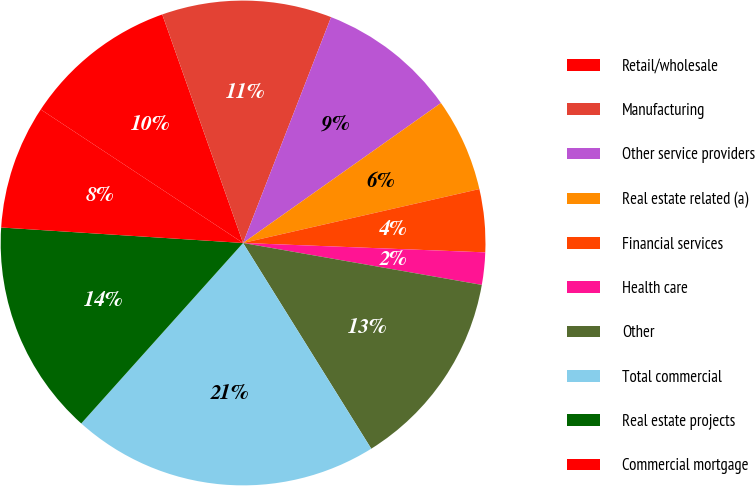Convert chart. <chart><loc_0><loc_0><loc_500><loc_500><pie_chart><fcel>Retail/wholesale<fcel>Manufacturing<fcel>Other service providers<fcel>Real estate related (a)<fcel>Financial services<fcel>Health care<fcel>Other<fcel>Total commercial<fcel>Real estate projects<fcel>Commercial mortgage<nl><fcel>10.31%<fcel>11.33%<fcel>9.29%<fcel>6.23%<fcel>4.19%<fcel>2.15%<fcel>13.37%<fcel>20.51%<fcel>14.39%<fcel>8.27%<nl></chart> 